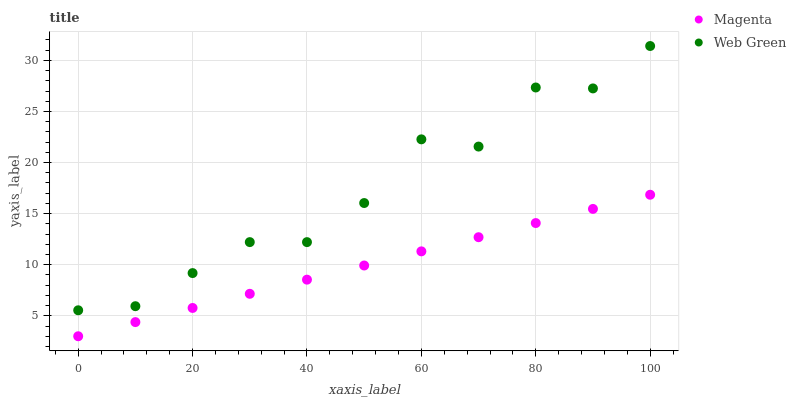Does Magenta have the minimum area under the curve?
Answer yes or no. Yes. Does Web Green have the maximum area under the curve?
Answer yes or no. Yes. Does Web Green have the minimum area under the curve?
Answer yes or no. No. Is Magenta the smoothest?
Answer yes or no. Yes. Is Web Green the roughest?
Answer yes or no. Yes. Is Web Green the smoothest?
Answer yes or no. No. Does Magenta have the lowest value?
Answer yes or no. Yes. Does Web Green have the lowest value?
Answer yes or no. No. Does Web Green have the highest value?
Answer yes or no. Yes. Is Magenta less than Web Green?
Answer yes or no. Yes. Is Web Green greater than Magenta?
Answer yes or no. Yes. Does Magenta intersect Web Green?
Answer yes or no. No. 